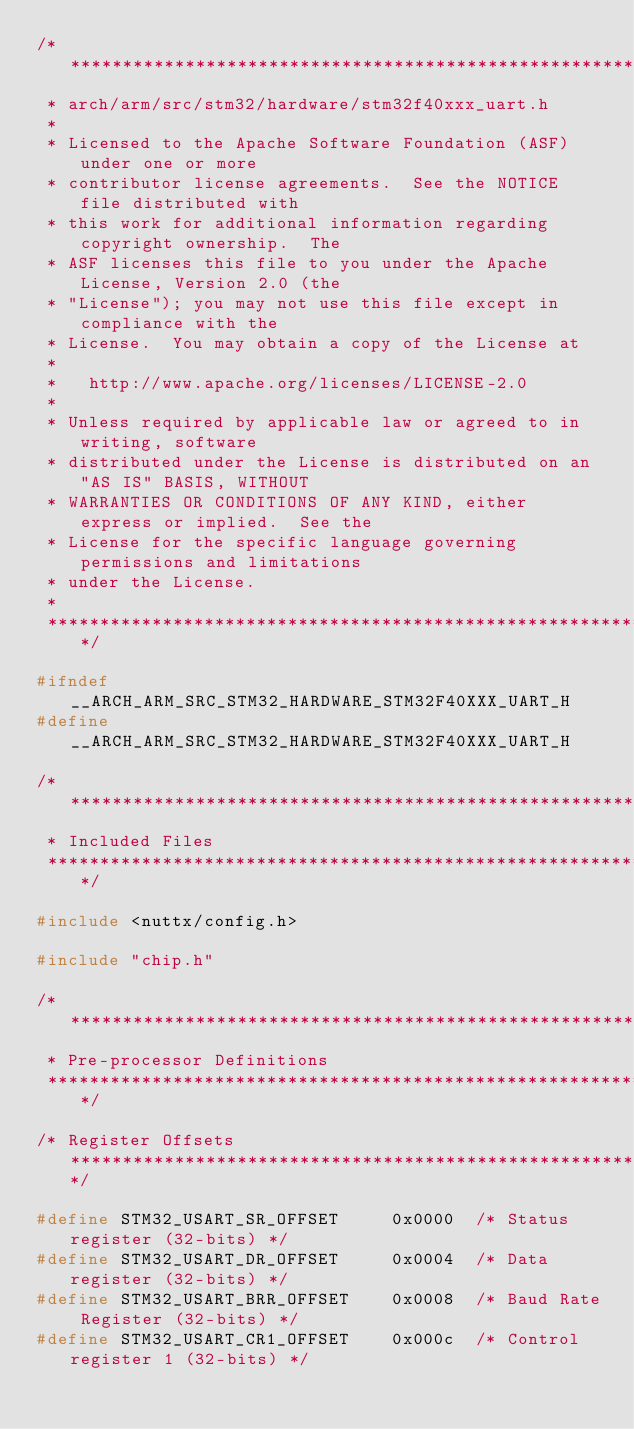<code> <loc_0><loc_0><loc_500><loc_500><_C_>/****************************************************************************
 * arch/arm/src/stm32/hardware/stm32f40xxx_uart.h
 *
 * Licensed to the Apache Software Foundation (ASF) under one or more
 * contributor license agreements.  See the NOTICE file distributed with
 * this work for additional information regarding copyright ownership.  The
 * ASF licenses this file to you under the Apache License, Version 2.0 (the
 * "License"); you may not use this file except in compliance with the
 * License.  You may obtain a copy of the License at
 *
 *   http://www.apache.org/licenses/LICENSE-2.0
 *
 * Unless required by applicable law or agreed to in writing, software
 * distributed under the License is distributed on an "AS IS" BASIS, WITHOUT
 * WARRANTIES OR CONDITIONS OF ANY KIND, either express or implied.  See the
 * License for the specific language governing permissions and limitations
 * under the License.
 *
 ****************************************************************************/

#ifndef __ARCH_ARM_SRC_STM32_HARDWARE_STM32F40XXX_UART_H
#define __ARCH_ARM_SRC_STM32_HARDWARE_STM32F40XXX_UART_H

/****************************************************************************
 * Included Files
 ****************************************************************************/

#include <nuttx/config.h>

#include "chip.h"

/****************************************************************************
 * Pre-processor Definitions
 ****************************************************************************/

/* Register Offsets *********************************************************/

#define STM32_USART_SR_OFFSET     0x0000  /* Status register (32-bits) */
#define STM32_USART_DR_OFFSET     0x0004  /* Data register (32-bits) */
#define STM32_USART_BRR_OFFSET    0x0008  /* Baud Rate Register (32-bits) */
#define STM32_USART_CR1_OFFSET    0x000c  /* Control register 1 (32-bits) */</code> 